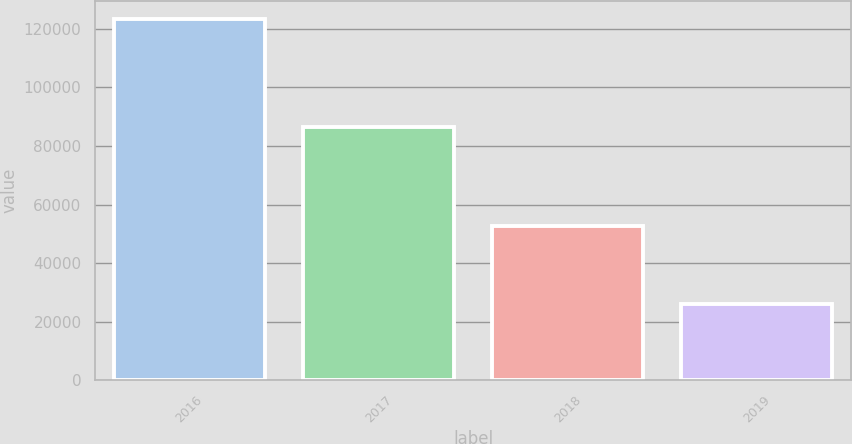Convert chart to OTSL. <chart><loc_0><loc_0><loc_500><loc_500><bar_chart><fcel>2016<fcel>2017<fcel>2018<fcel>2019<nl><fcel>123388<fcel>86546<fcel>52776<fcel>25928<nl></chart> 